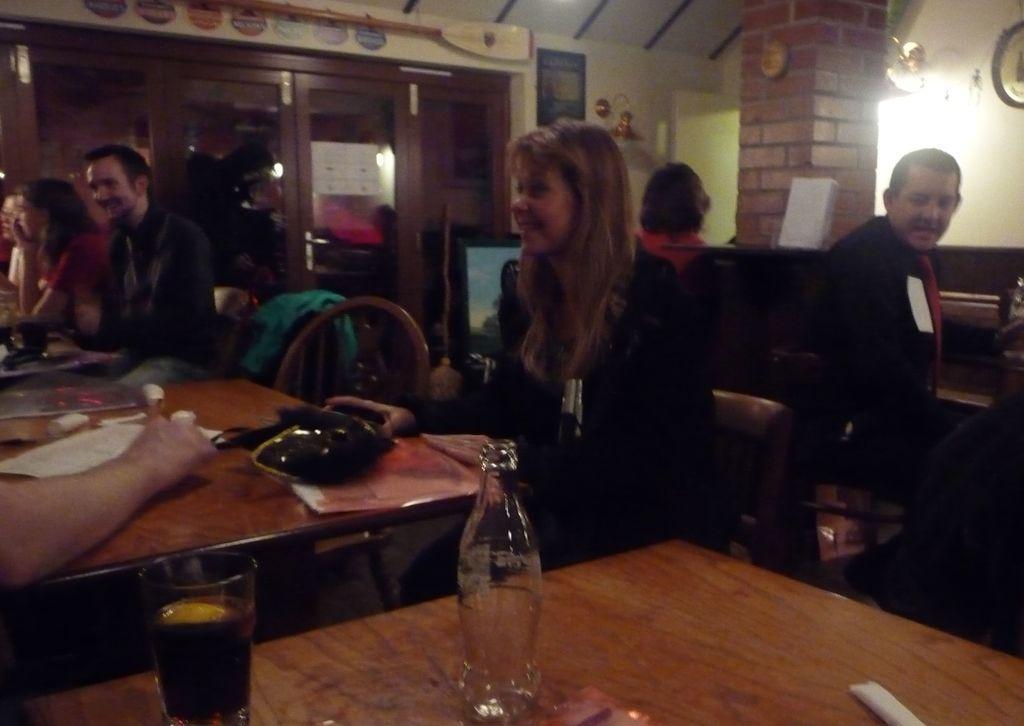In one or two sentences, can you explain what this image depicts? In this picture we can see a group of people sitting on chairs and in front of them there is table and on table we can see bottle, glass with drink in it, paper and in background we can see pillar, clock. 